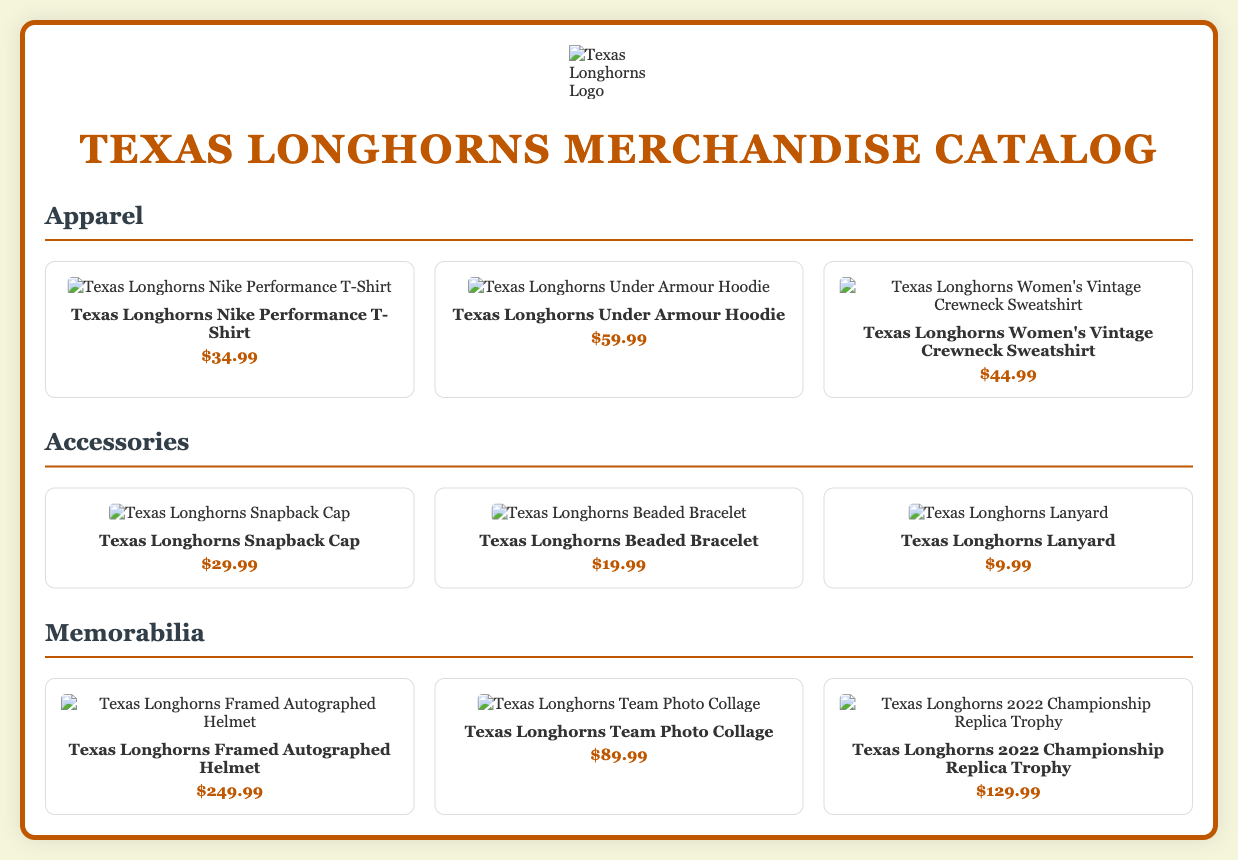what is the price of the Texas Longhorns Nike Performance T-Shirt? The price of the Texas Longhorns Nike Performance T-Shirt is listed in the catalog.
Answer: $34.99 how many accessories are listed in the catalog? The catalog contains a section for accessories, and it lists three products.
Answer: 3 what type of memorabilia is available for purchase? The memorabilia section includes items that are specific to Texas Longhorns, which can be identified by their names.
Answer: Framed Autographed Helmet, Team Photo Collage, Championship Replica Trophy what is the price of the Texas Longhorns Beaded Bracelet? The price is mentioned next to the product description in the accessories section.
Answer: $19.99 which apparel item is the most expensive? By comparing the prices of the apparel items listed, we can identify the most expensive one.
Answer: Texas Longhorns Under Armour Hoodie how many product categories are there in the catalog? The document outlines different sections with distinct categories for products.
Answer: 3 what is the image of the Texas Longhorns Snapback Cap? Each product features a specific image associated with it in the accessories section of the catalog.
Answer: ![Texas Longhorns Snapback Cap](https://example.com/images/snapback-cap.jpg) what is the total price of all the items in the memorabilia section? To find the total, we add the prices of each memorabilia item listed in the document.
Answer: $469.97 